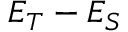Convert formula to latex. <formula><loc_0><loc_0><loc_500><loc_500>E _ { T } - E _ { S }</formula> 